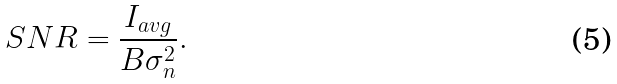Convert formula to latex. <formula><loc_0><loc_0><loc_500><loc_500>S N R = \frac { I _ { a v g } } { B \sigma _ { n } ^ { 2 } } .</formula> 